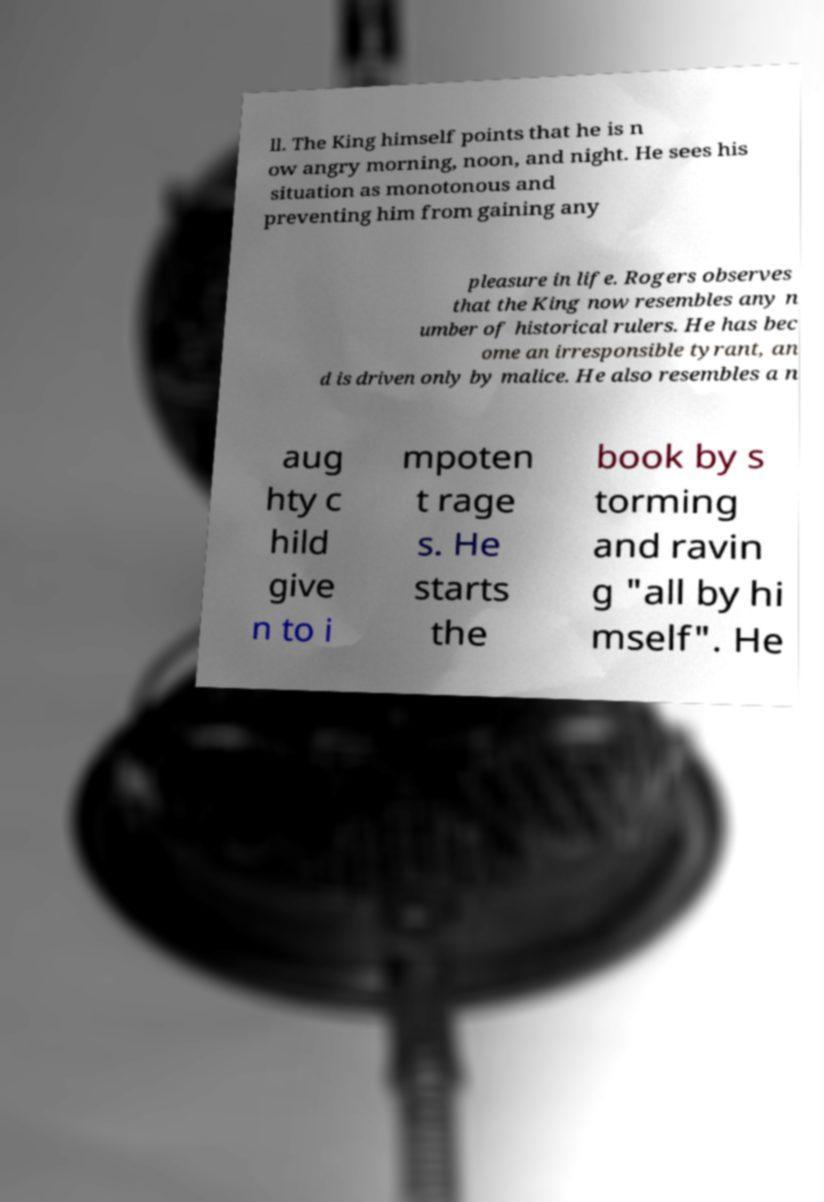What messages or text are displayed in this image? I need them in a readable, typed format. ll. The King himself points that he is n ow angry morning, noon, and night. He sees his situation as monotonous and preventing him from gaining any pleasure in life. Rogers observes that the King now resembles any n umber of historical rulers. He has bec ome an irresponsible tyrant, an d is driven only by malice. He also resembles a n aug hty c hild give n to i mpoten t rage s. He starts the book by s torming and ravin g "all by hi mself". He 